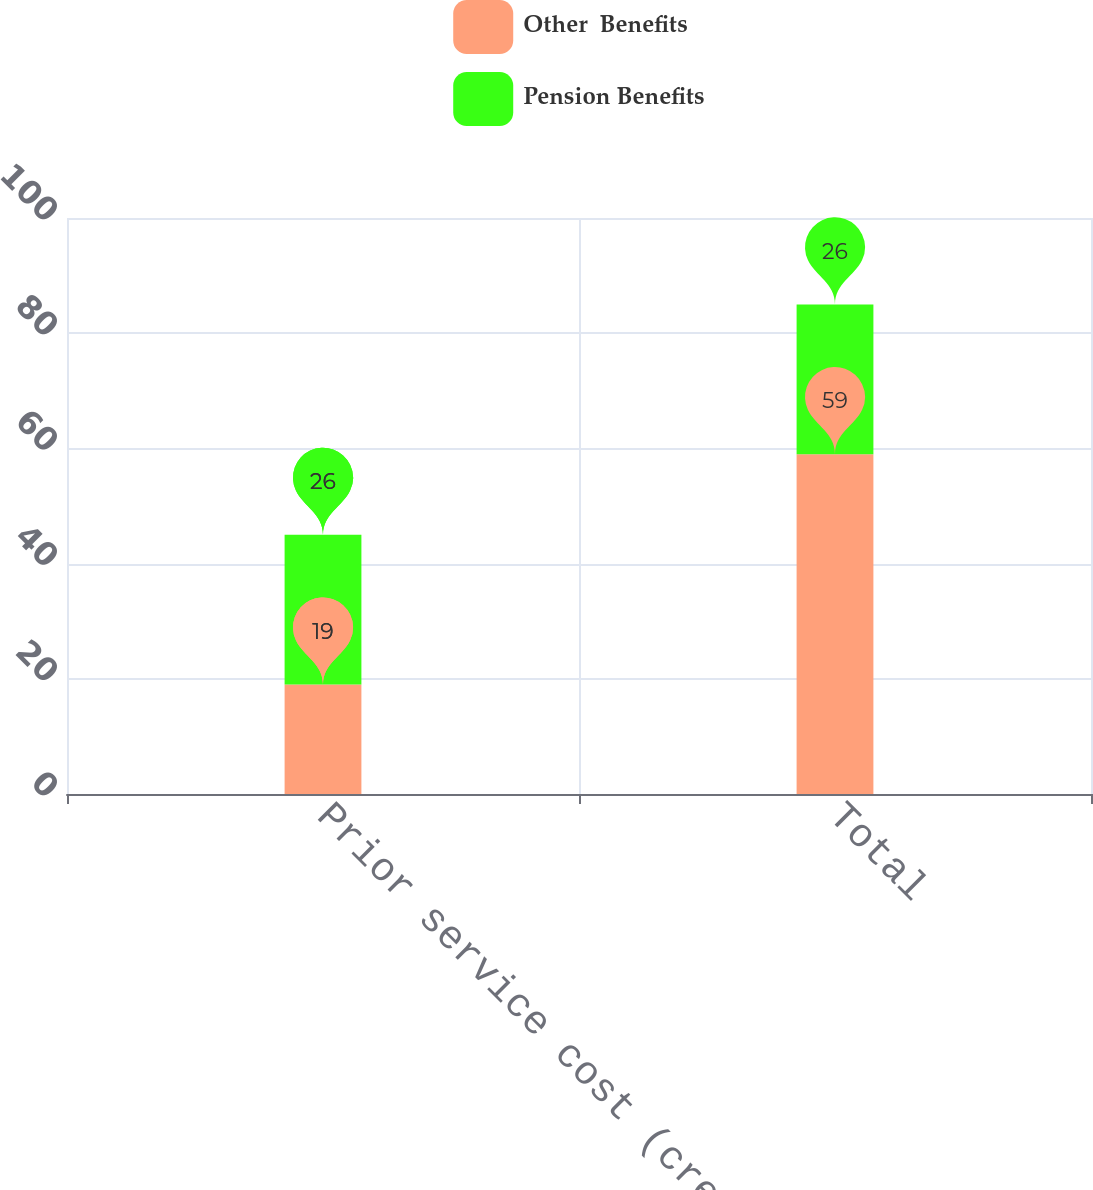Convert chart to OTSL. <chart><loc_0><loc_0><loc_500><loc_500><stacked_bar_chart><ecel><fcel>Prior service cost (credit)<fcel>Total<nl><fcel>Other  Benefits<fcel>19<fcel>59<nl><fcel>Pension Benefits<fcel>26<fcel>26<nl></chart> 